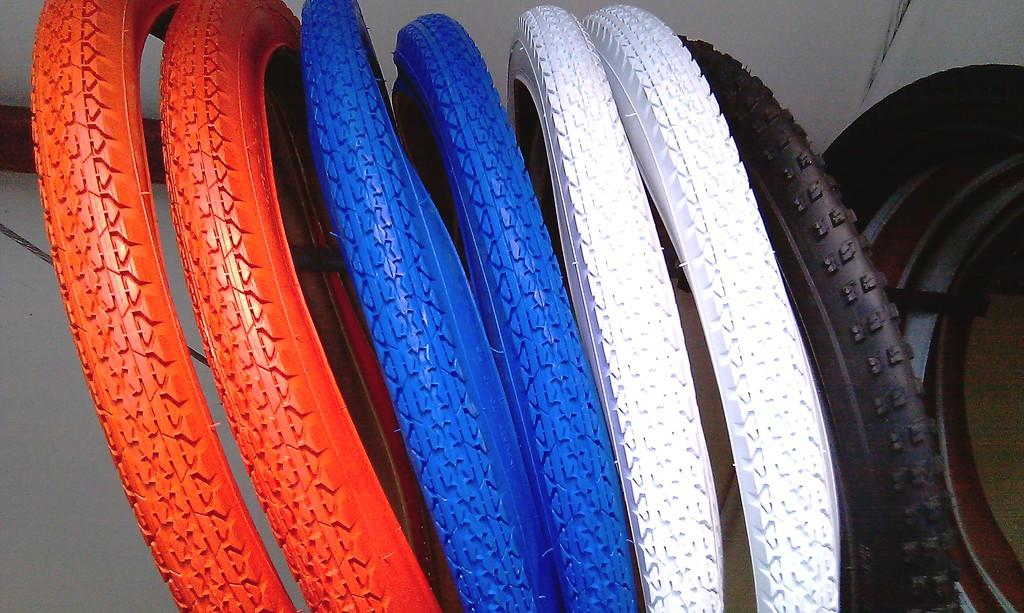What objects are present in the image? There are tires in the image. Can you describe the colors of the tires? The tires are in red, blue, white, and black colors. What is the color of the background in the image? The background is in white color. What type of drum can be heard playing in the background of the image? There is no drum or sound present in the image; it only features tires and their colors. 